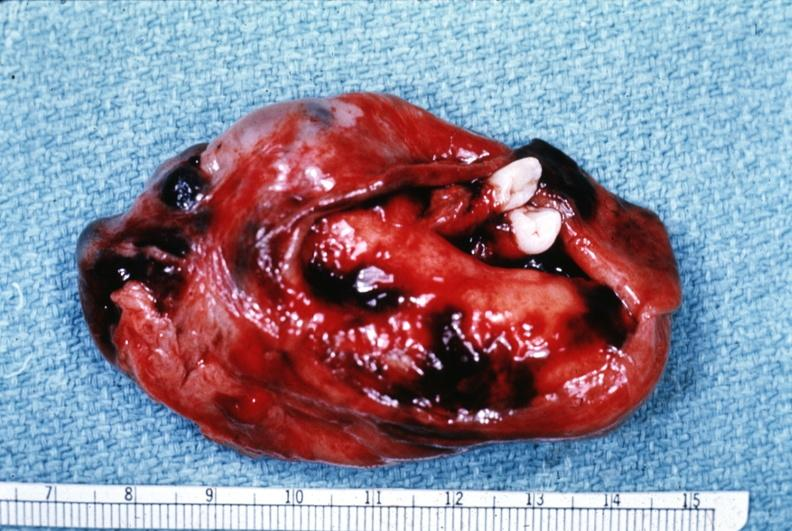where does this belong to?
Answer the question using a single word or phrase. Female reproductive system 